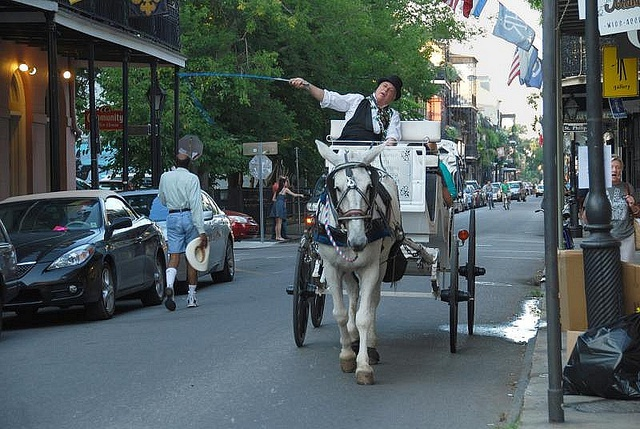Describe the objects in this image and their specific colors. I can see car in black, blue, darkblue, and gray tones, horse in black, gray, darkgray, and lightgray tones, people in black, lightgray, darkgray, and gray tones, people in black, gray, lightblue, and darkgray tones, and car in black, gray, and blue tones in this image. 